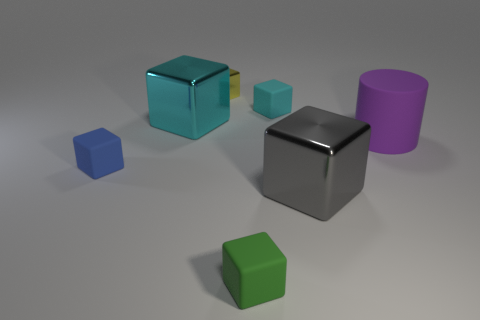What color is the cylinder that is the same material as the green block? In the image, no cylinder shares the same material as the green block, as the materials of the objects shown vary. The green block has a unique matte finish, whereas the cylinder is purple with a different, perhaps more reflective surface finish. 